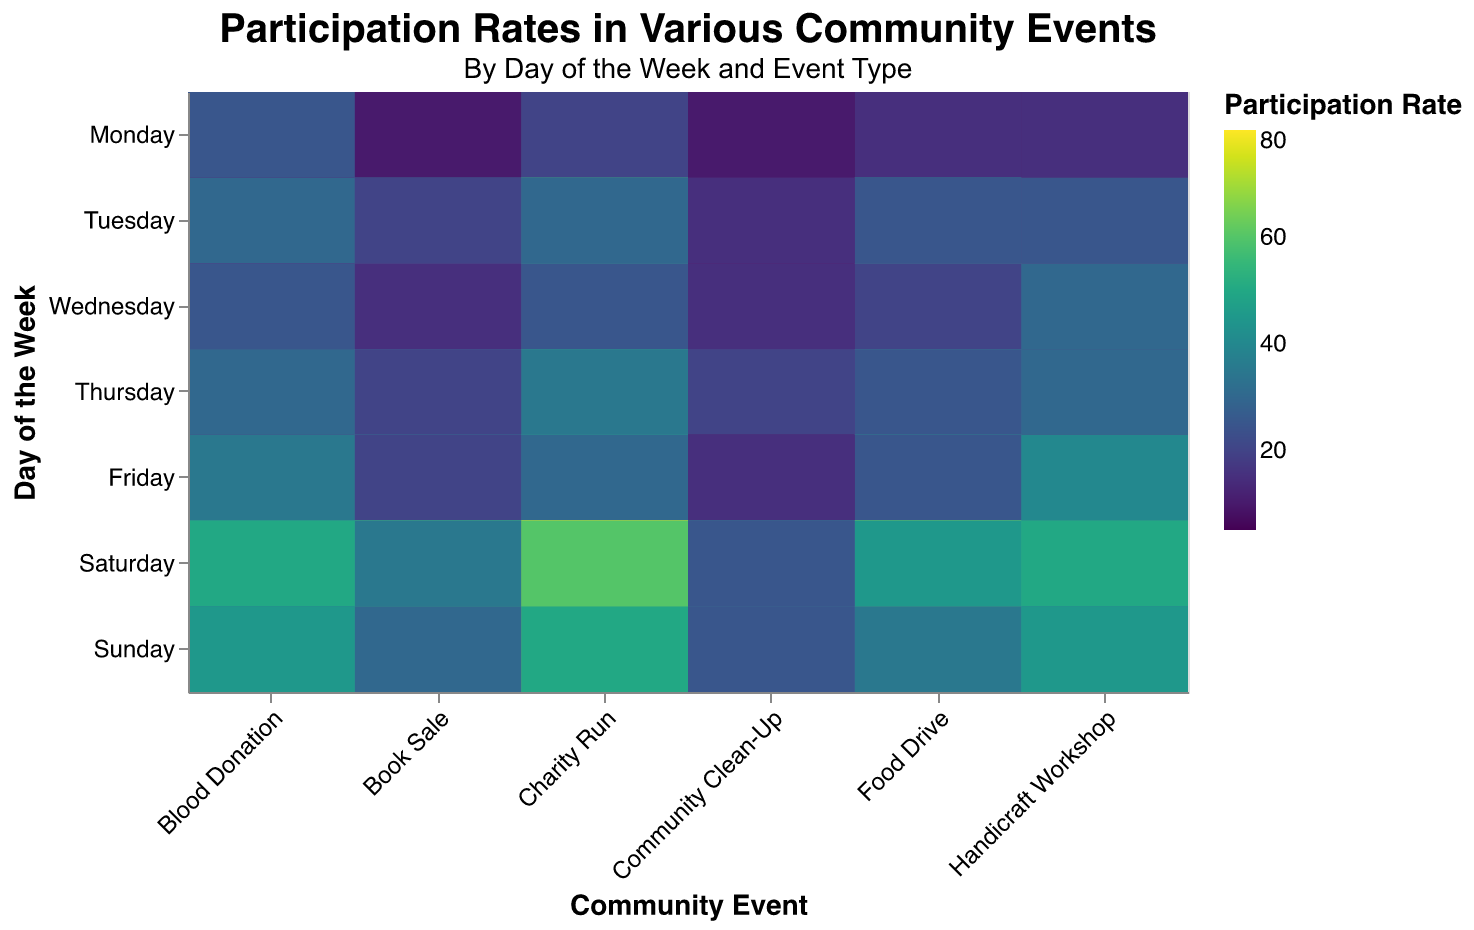Which event has the highest participation on Saturday morning? On Saturday morning, the Charity Run has the highest participation of 80.
Answer: Charity Run What is the participation rate for the Handicraft Workshop on Tuesday afternoon? On Tuesday afternoon, the Handicraft Workshop has a participation rate of 20.
Answer: 20 How does the participation rate for Blood Donation on Friday evening compare to Wednesday evening? On Friday evening, the participation rate for Blood Donation is 35. On Wednesday evening, it is 25. Therefore, Friday evening has a higher participation rate by 10.
Answer: Friday evening is higher by 10 Which day and time have the lowest participation for the Handicraft Workshop? The lowest participation for the Handicraft Workshop is on Monday morning, with a rate of 5.
Answer: Monday morning Calculate the average participation rate for the Community Clean-Up event on weekends (Saturday and Sunday). On Saturday, the rates are 40 (morning), 30 (afternoon), and 25 (evening). On Sunday, they are 35 (morning), 30 (afternoon), and 25 (evening). The average is (40 + 30 + 25 + 35 + 30 + 25) / 6 = 30.83.
Answer: 30.83 Which community event has the most uniform participation rates throughout the week? Community Clean-Up has the most uniform participation rates, with rates distributed fairly evenly across the different days and times.
Answer: Community Clean-Up Compare and contrast the participation rates of the Food Drive event on Monday and Saturday. On Monday, the rates are 30 (morning), 25 (afternoon), and 15 (evening). On Saturday, they are 60 (morning), 65 (afternoon), and 45 (evening). Saturday has consistently higher participation rates compared to Monday.
Answer: Saturday has higher rates Identify the time of day with the highest overall participation for all events combined. Saturday morning has the highest overall participation when considering the combined rates of all events.
Answer: Saturday morning What is the participation trend for Charity Run from Monday to Sunday? Participation for the Charity Run generally increases from Monday (50) to Thursday (55), drops on Friday (45), peaks on Saturday (80), and then slightly decreases on Sunday (70).
Answer: Increases to peak Saturday, slight decrease Sunday Which event shows a significant increase in participation from Thursday evening to Friday evening? Handicraft Workshop shows a significant increase in participation from 30 on Thursday evening to 40 on Friday evening.
Answer: Handicraft Workshop 